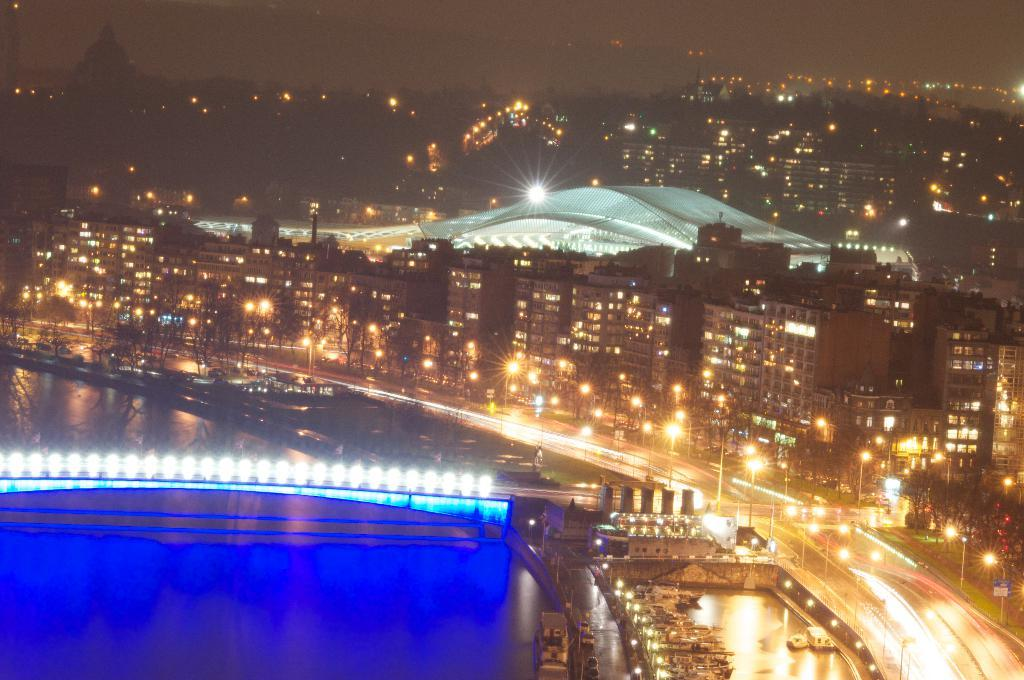What can be seen on the left side of the image? There is water on the left side of the image. What structure is present in the image? There is a bridge with lights in the image. What else is illuminated in the image? There are many buildings with lights in the image. What is the primary mode of transportation in the image? There is a road in the image, which suggests that vehicles might be used for transportation. How would you describe the overall lighting in the image? The background of the image is dark, but the bridge, buildings, and road are illuminated with lights. Where is the locket hanging from in the image? There is no locket present in the image. What type of branch can be seen growing from the water in the image? There is no branch visible in the image; it features water, a bridge, buildings, and a road. 